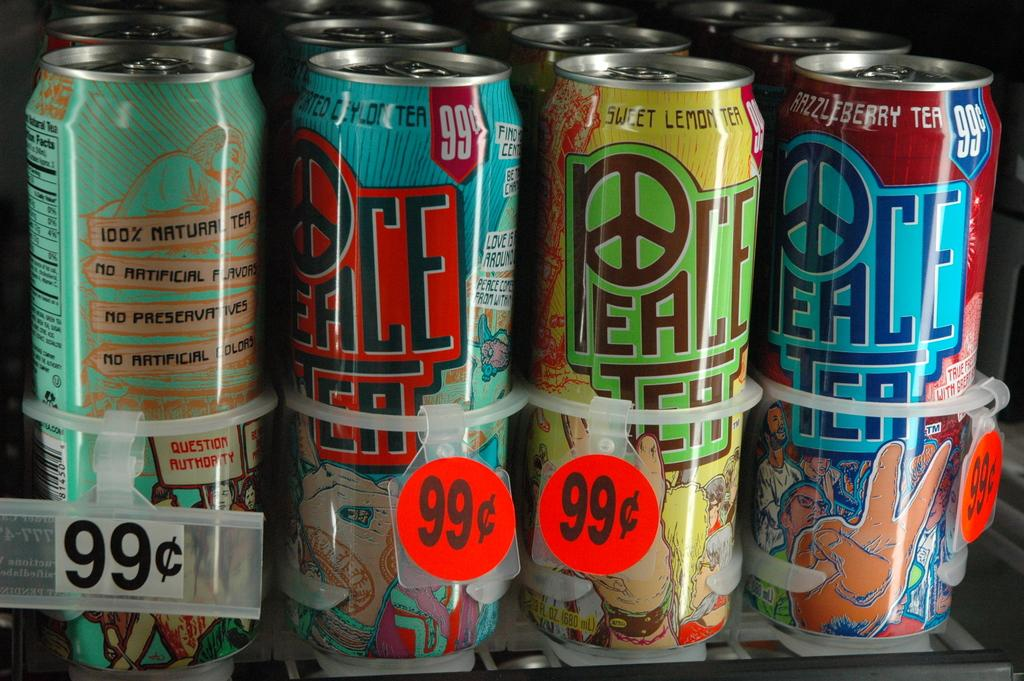<image>
Provide a brief description of the given image. Several cans of Peace Tea are 99 cents in a drink cooler, including the flavors Sweet Lemon Tea and Razzleberry Tea. 